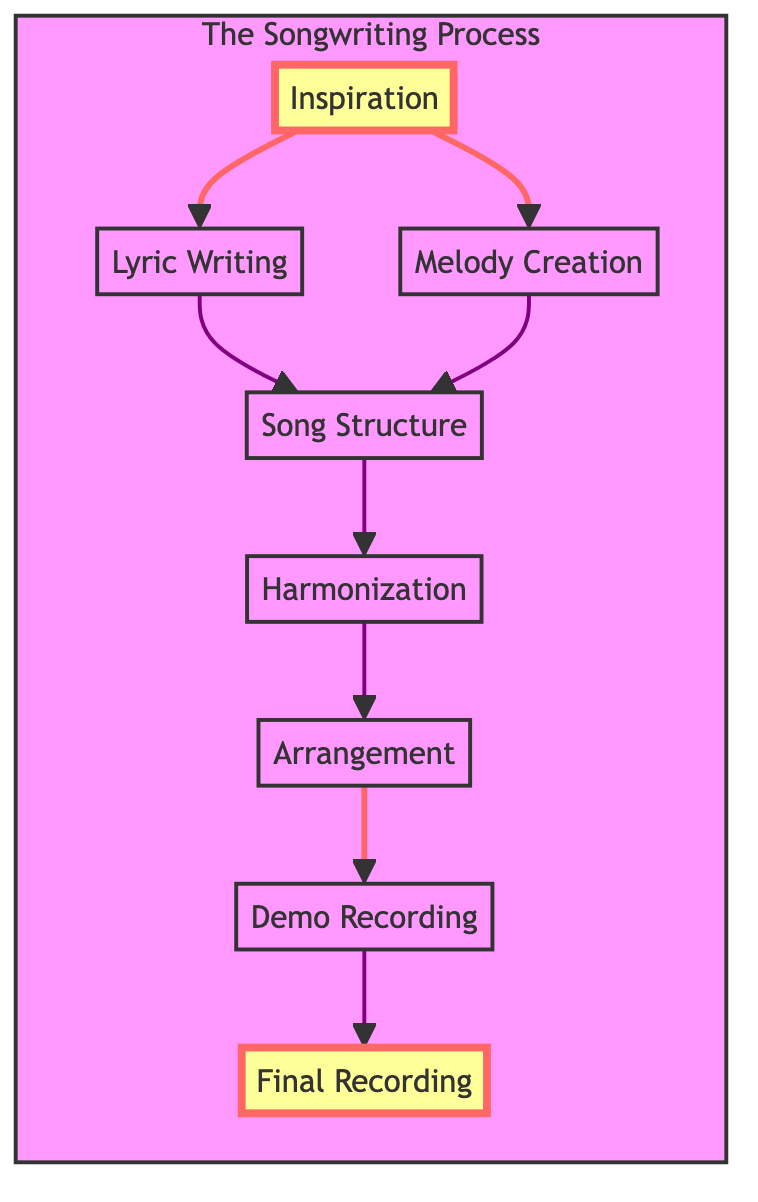What is the first step in the song composition process? The diagram lists "Inspiration" as the first step, which serves as the catalyst for songwriting. This is indicated by it being the top node from which other steps branch out.
Answer: Inspiration How many steps are there in the process of composing a song? The diagram has eight distinct nodes that represent different steps in the composition process, indicating there are eight steps in total.
Answer: 8 What follows after "Lyric Writing"? According to the diagram, "Song Structure" follows "Lyric Writing" as the next step in the song composition process, connecting through a direct flow line from one to the other.
Answer: Song Structure Which step involves adding chords to the melody? The step that involves adding chords and harmonies to support the melody is "Harmonization," as depicted immediately following "Song Structure" in the flow.
Answer: Harmonization What is the last step in the song composition process? The diagram identifies "Final Recording" as the last step in the song composition process, which is the final node in the flow and signifies the completion of the composition.
Answer: Final Recording What are the two steps that directly lead to "Song Structure"? The two steps that lead directly to "Song Structure" are "Lyric Writing" and "Melody Creation," both of which branch out to connect with "Song Structure."
Answer: Lyric Writing, Melody Creation How many connections lead into the "Arrangement" step? The diagram shows that there is only one connection leading into the "Arrangement" step, which comes from "Harmonization," indicating that "Harmonization" must precede "Arrangement."
Answer: 1 Which step is connected to the "Demo Recording"? According to the diagram, the step directly before "Demo Recording" is "Arrangement," which must occur for a demo to be created.
Answer: Arrangement 